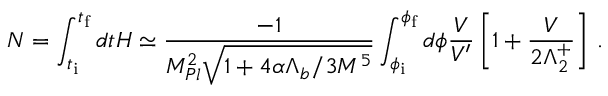Convert formula to latex. <formula><loc_0><loc_0><loc_500><loc_500>N = \int _ { t _ { i } } ^ { t _ { f } } d t H \simeq \frac { - 1 } { M _ { P l } ^ { 2 } \sqrt { 1 + 4 \alpha \Lambda _ { b } / 3 M ^ { 5 } } } \int _ { \phi _ { i } } ^ { \phi _ { f } } d \phi { \frac { V } { V ^ { \prime } } } \left [ 1 + { \frac { V } { 2 \Lambda _ { 2 } ^ { + } } } \right ] \, .</formula> 